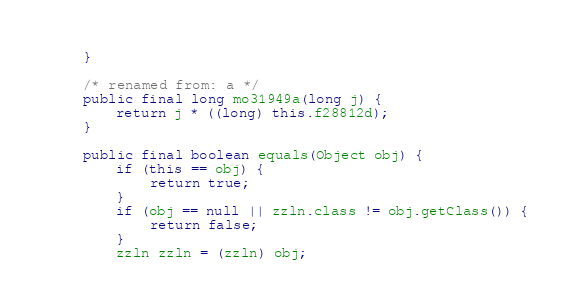Convert code to text. <code><loc_0><loc_0><loc_500><loc_500><_Java_>    }

    /* renamed from: a */
    public final long mo31949a(long j) {
        return j * ((long) this.f28812d);
    }

    public final boolean equals(Object obj) {
        if (this == obj) {
            return true;
        }
        if (obj == null || zzln.class != obj.getClass()) {
            return false;
        }
        zzln zzln = (zzln) obj;</code> 